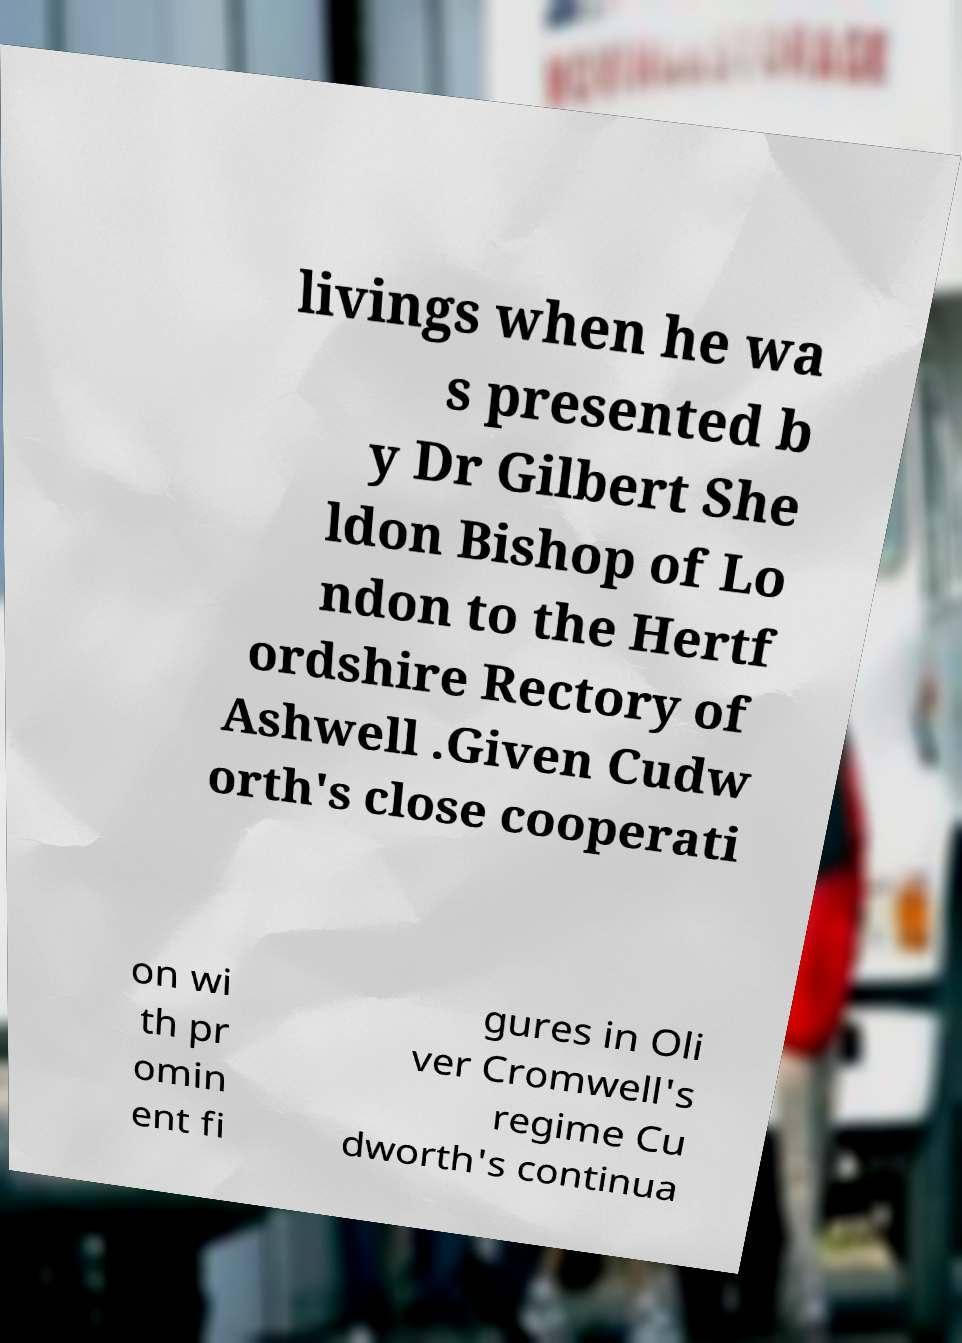I need the written content from this picture converted into text. Can you do that? livings when he wa s presented b y Dr Gilbert She ldon Bishop of Lo ndon to the Hertf ordshire Rectory of Ashwell .Given Cudw orth's close cooperati on wi th pr omin ent fi gures in Oli ver Cromwell's regime Cu dworth's continua 